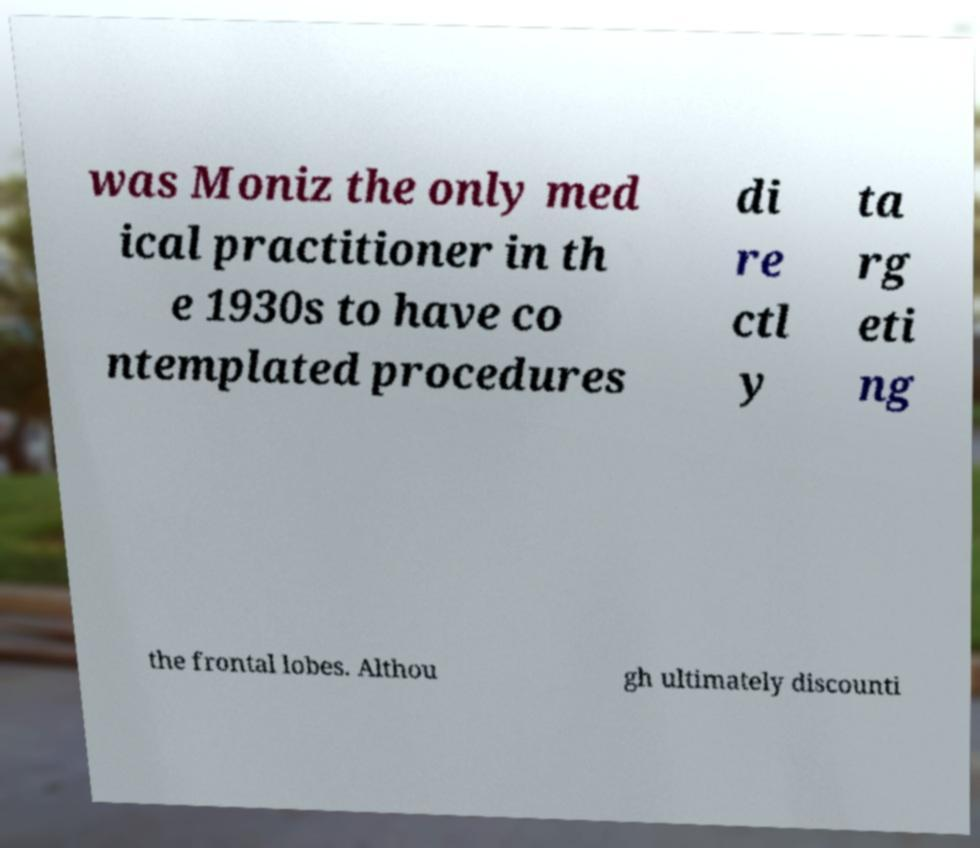Can you accurately transcribe the text from the provided image for me? was Moniz the only med ical practitioner in th e 1930s to have co ntemplated procedures di re ctl y ta rg eti ng the frontal lobes. Althou gh ultimately discounti 